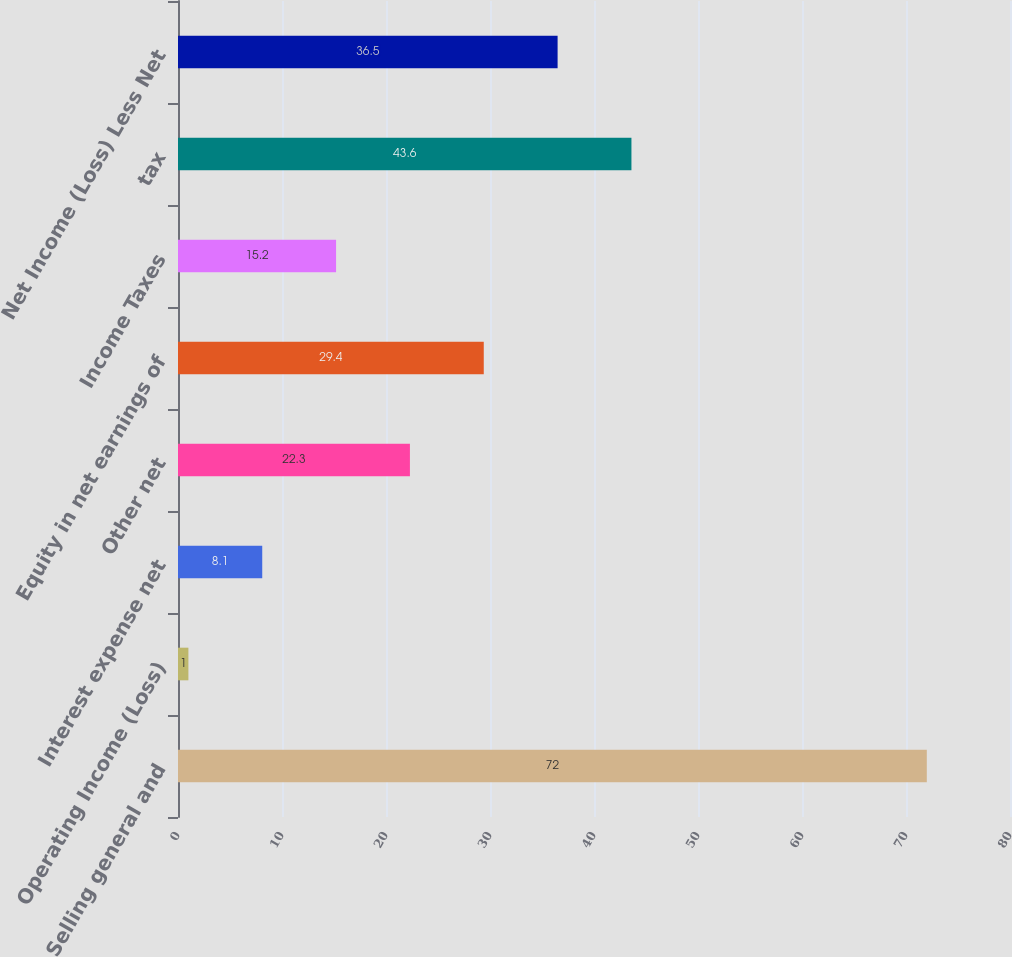Convert chart to OTSL. <chart><loc_0><loc_0><loc_500><loc_500><bar_chart><fcel>Selling general and<fcel>Operating Income (Loss)<fcel>Interest expense net<fcel>Other net<fcel>Equity in net earnings of<fcel>Income Taxes<fcel>tax<fcel>Net Income (Loss) Less Net<nl><fcel>72<fcel>1<fcel>8.1<fcel>22.3<fcel>29.4<fcel>15.2<fcel>43.6<fcel>36.5<nl></chart> 